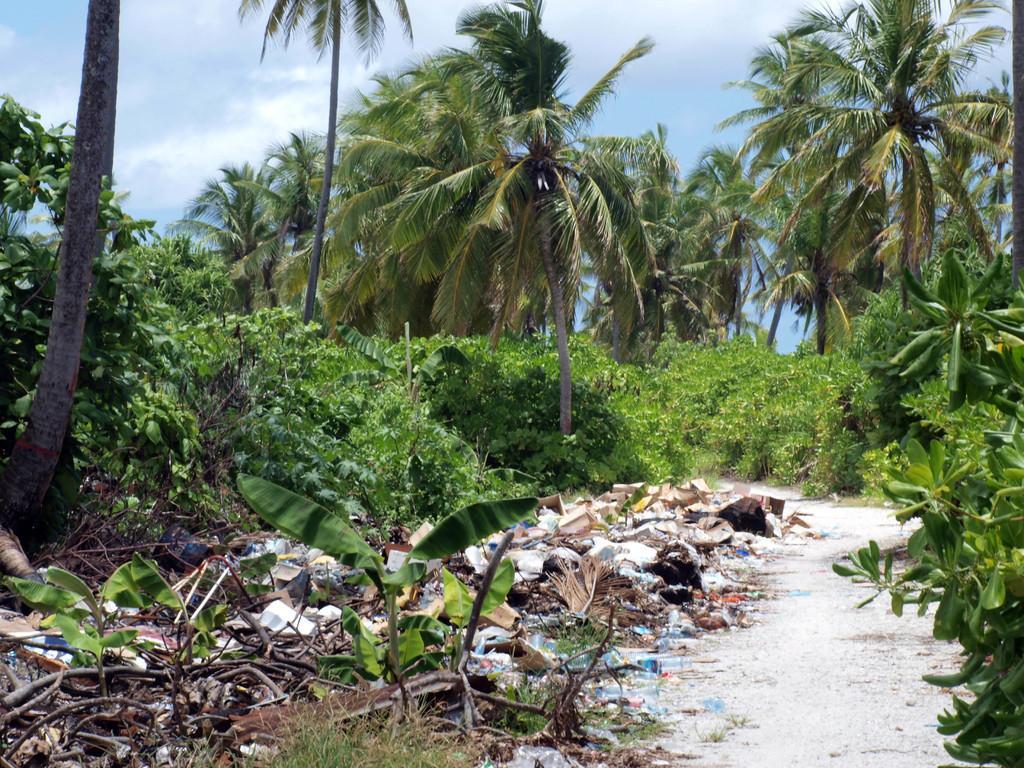How would you summarize this image in a sentence or two? In the image there is path on the right side with trees and plants on either side of it and above its sky with clouds. 